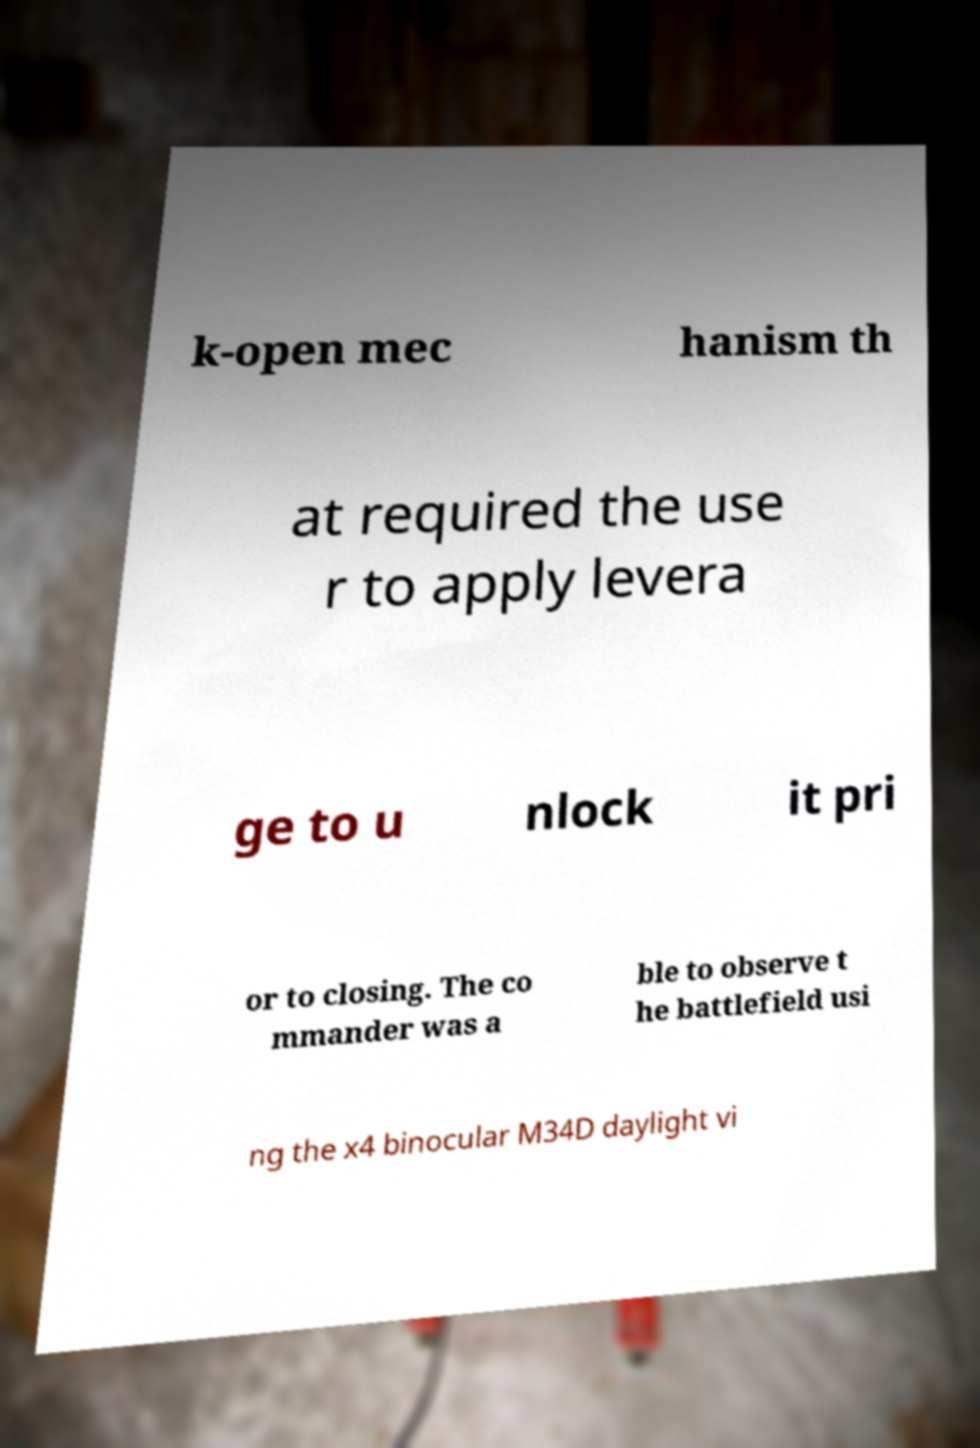For documentation purposes, I need the text within this image transcribed. Could you provide that? k-open mec hanism th at required the use r to apply levera ge to u nlock it pri or to closing. The co mmander was a ble to observe t he battlefield usi ng the x4 binocular M34D daylight vi 